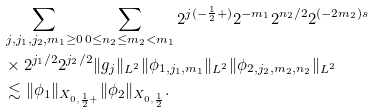<formula> <loc_0><loc_0><loc_500><loc_500>& \sum _ { j , j _ { 1 } , j _ { 2 } , m _ { 1 } \geq 0 } \sum _ { 0 \leq n _ { 2 } \leq m _ { 2 } < m _ { 1 } } 2 ^ { j ( - \frac { 1 } { 2 } + ) } 2 ^ { - m _ { 1 } } 2 ^ { n _ { 2 } / 2 } 2 ^ { ( - 2 m _ { 2 } ) s } \\ & \times 2 ^ { j _ { 1 } / 2 } 2 ^ { j _ { 2 } / 2 } \| g _ { j } \| _ { L ^ { 2 } } \| \phi _ { 1 , j _ { 1 } , m _ { 1 } } \| _ { L ^ { 2 } } \| \phi _ { 2 , j _ { 2 } , m _ { 2 } , n _ { 2 } } \| _ { L ^ { 2 } } \\ & \lesssim \| \phi _ { 1 } \| _ { X _ { 0 , \frac { 1 } { 2 } + } } \| \phi _ { 2 } \| _ { X _ { 0 , \frac { 1 } { 2 } } } .</formula> 